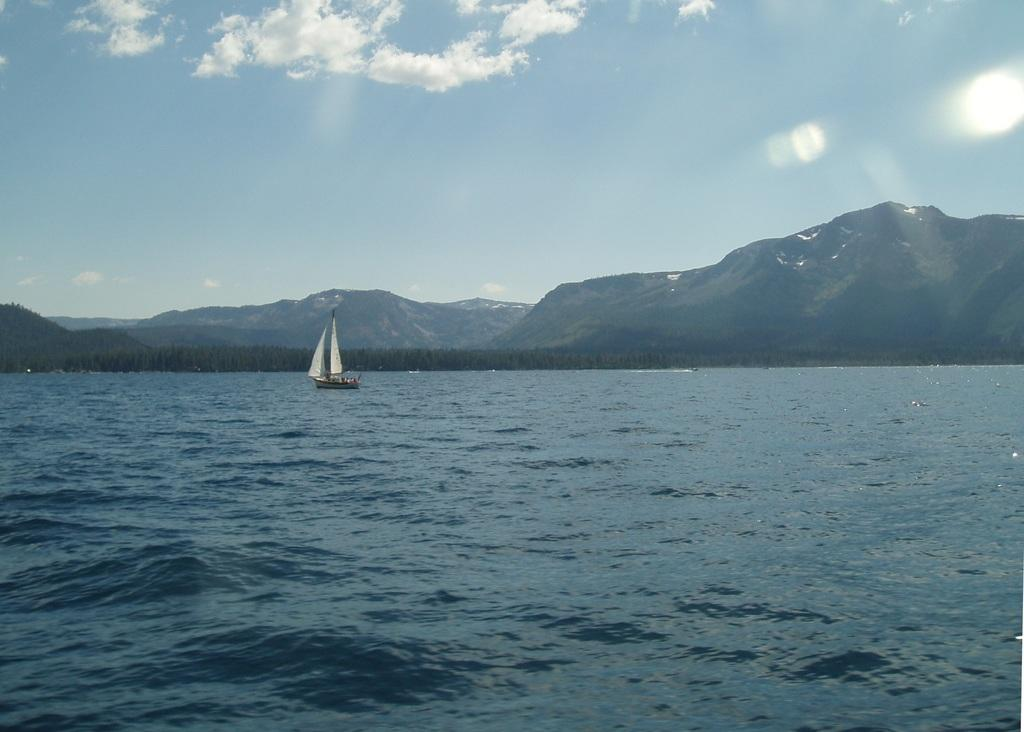What type of natural feature is present in the image? There is an ocean in the image. What is floating on the water in the image? There is a boat floating on the water on the left side of the image. What can be seen in the distance in the image? There are hills visible in the background of the image. What is visible in the sky in the background of the image? There are clouds in the sky in the background of the image. How many bears can be seen in the image? There are no bears present in the image. What type of fang is visible on the boat in the image? There is no fang present in the image; it features a boat floating on the water. 